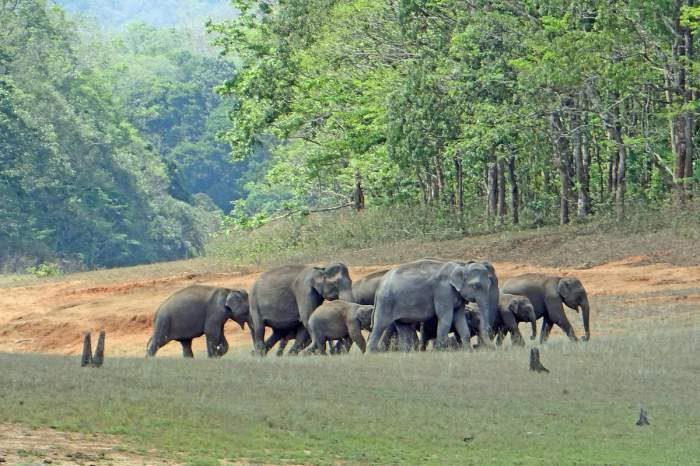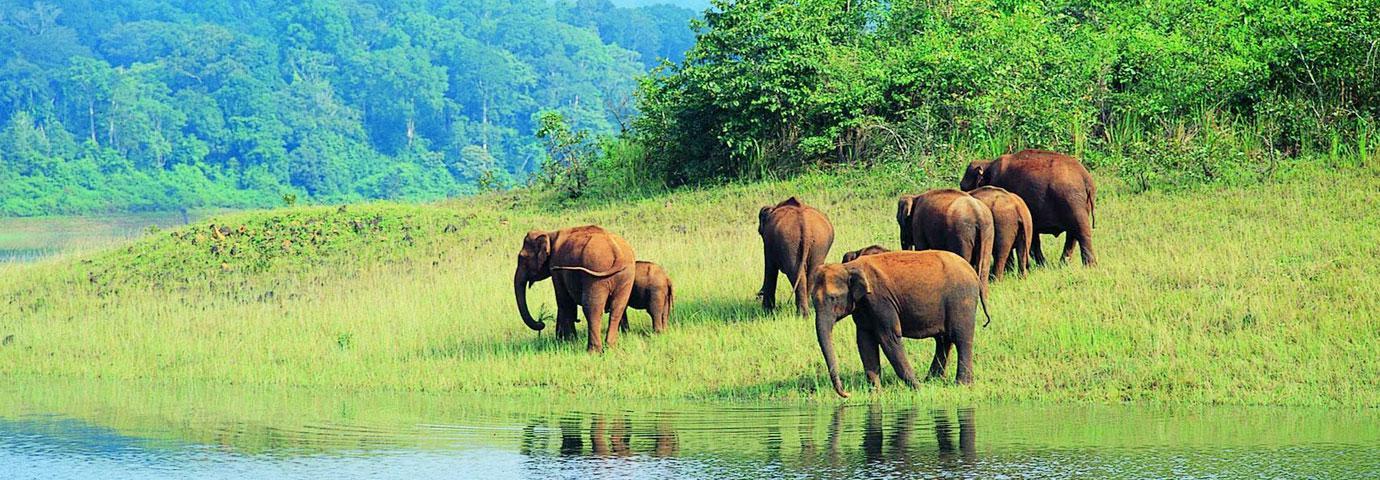The first image is the image on the left, the second image is the image on the right. Assess this claim about the two images: "An image shows a group of elephants near a pool of water, but not in the water.". Correct or not? Answer yes or no. Yes. The first image is the image on the left, the second image is the image on the right. Considering the images on both sides, is "The animals in the image on the right are near watere." valid? Answer yes or no. Yes. 